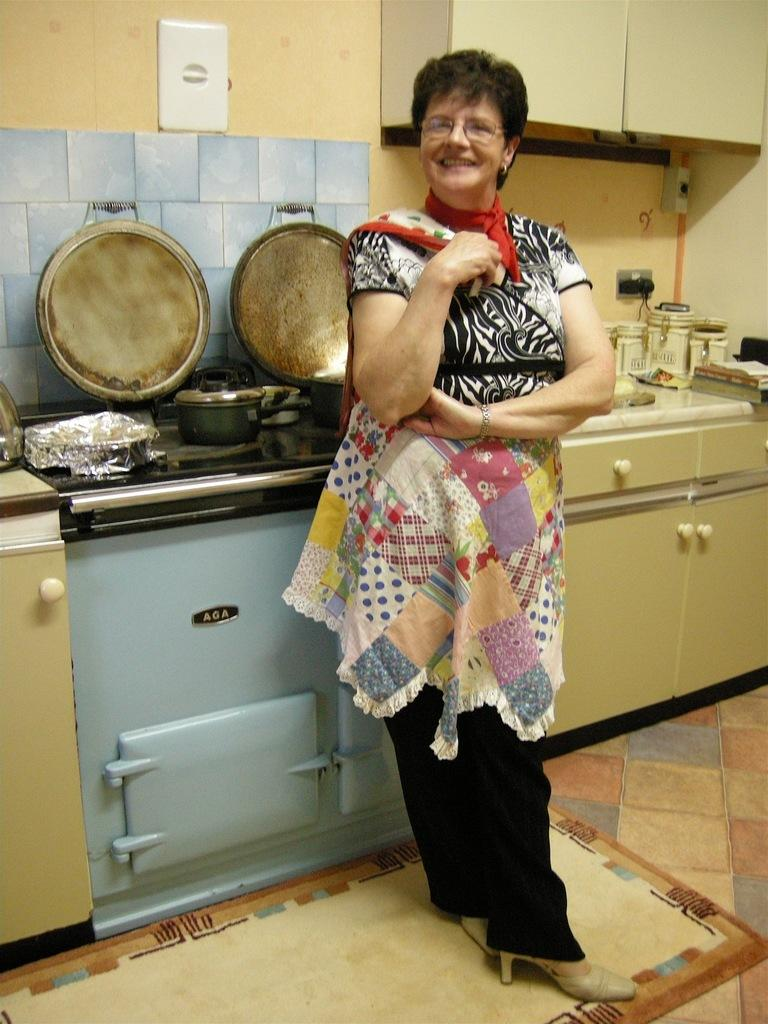<image>
Create a compact narrative representing the image presented. A woman stands smiling in front of an AGA stove. 